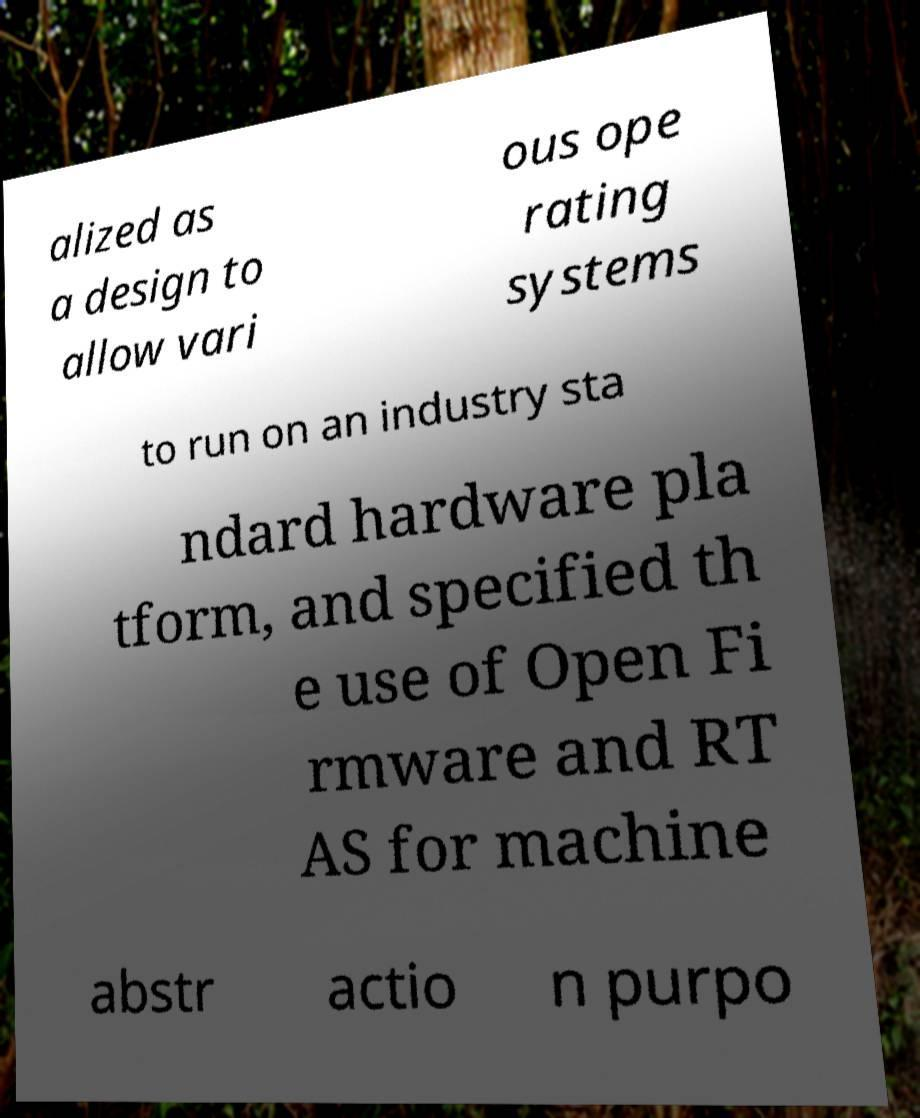Can you read and provide the text displayed in the image?This photo seems to have some interesting text. Can you extract and type it out for me? alized as a design to allow vari ous ope rating systems to run on an industry sta ndard hardware pla tform, and specified th e use of Open Fi rmware and RT AS for machine abstr actio n purpo 